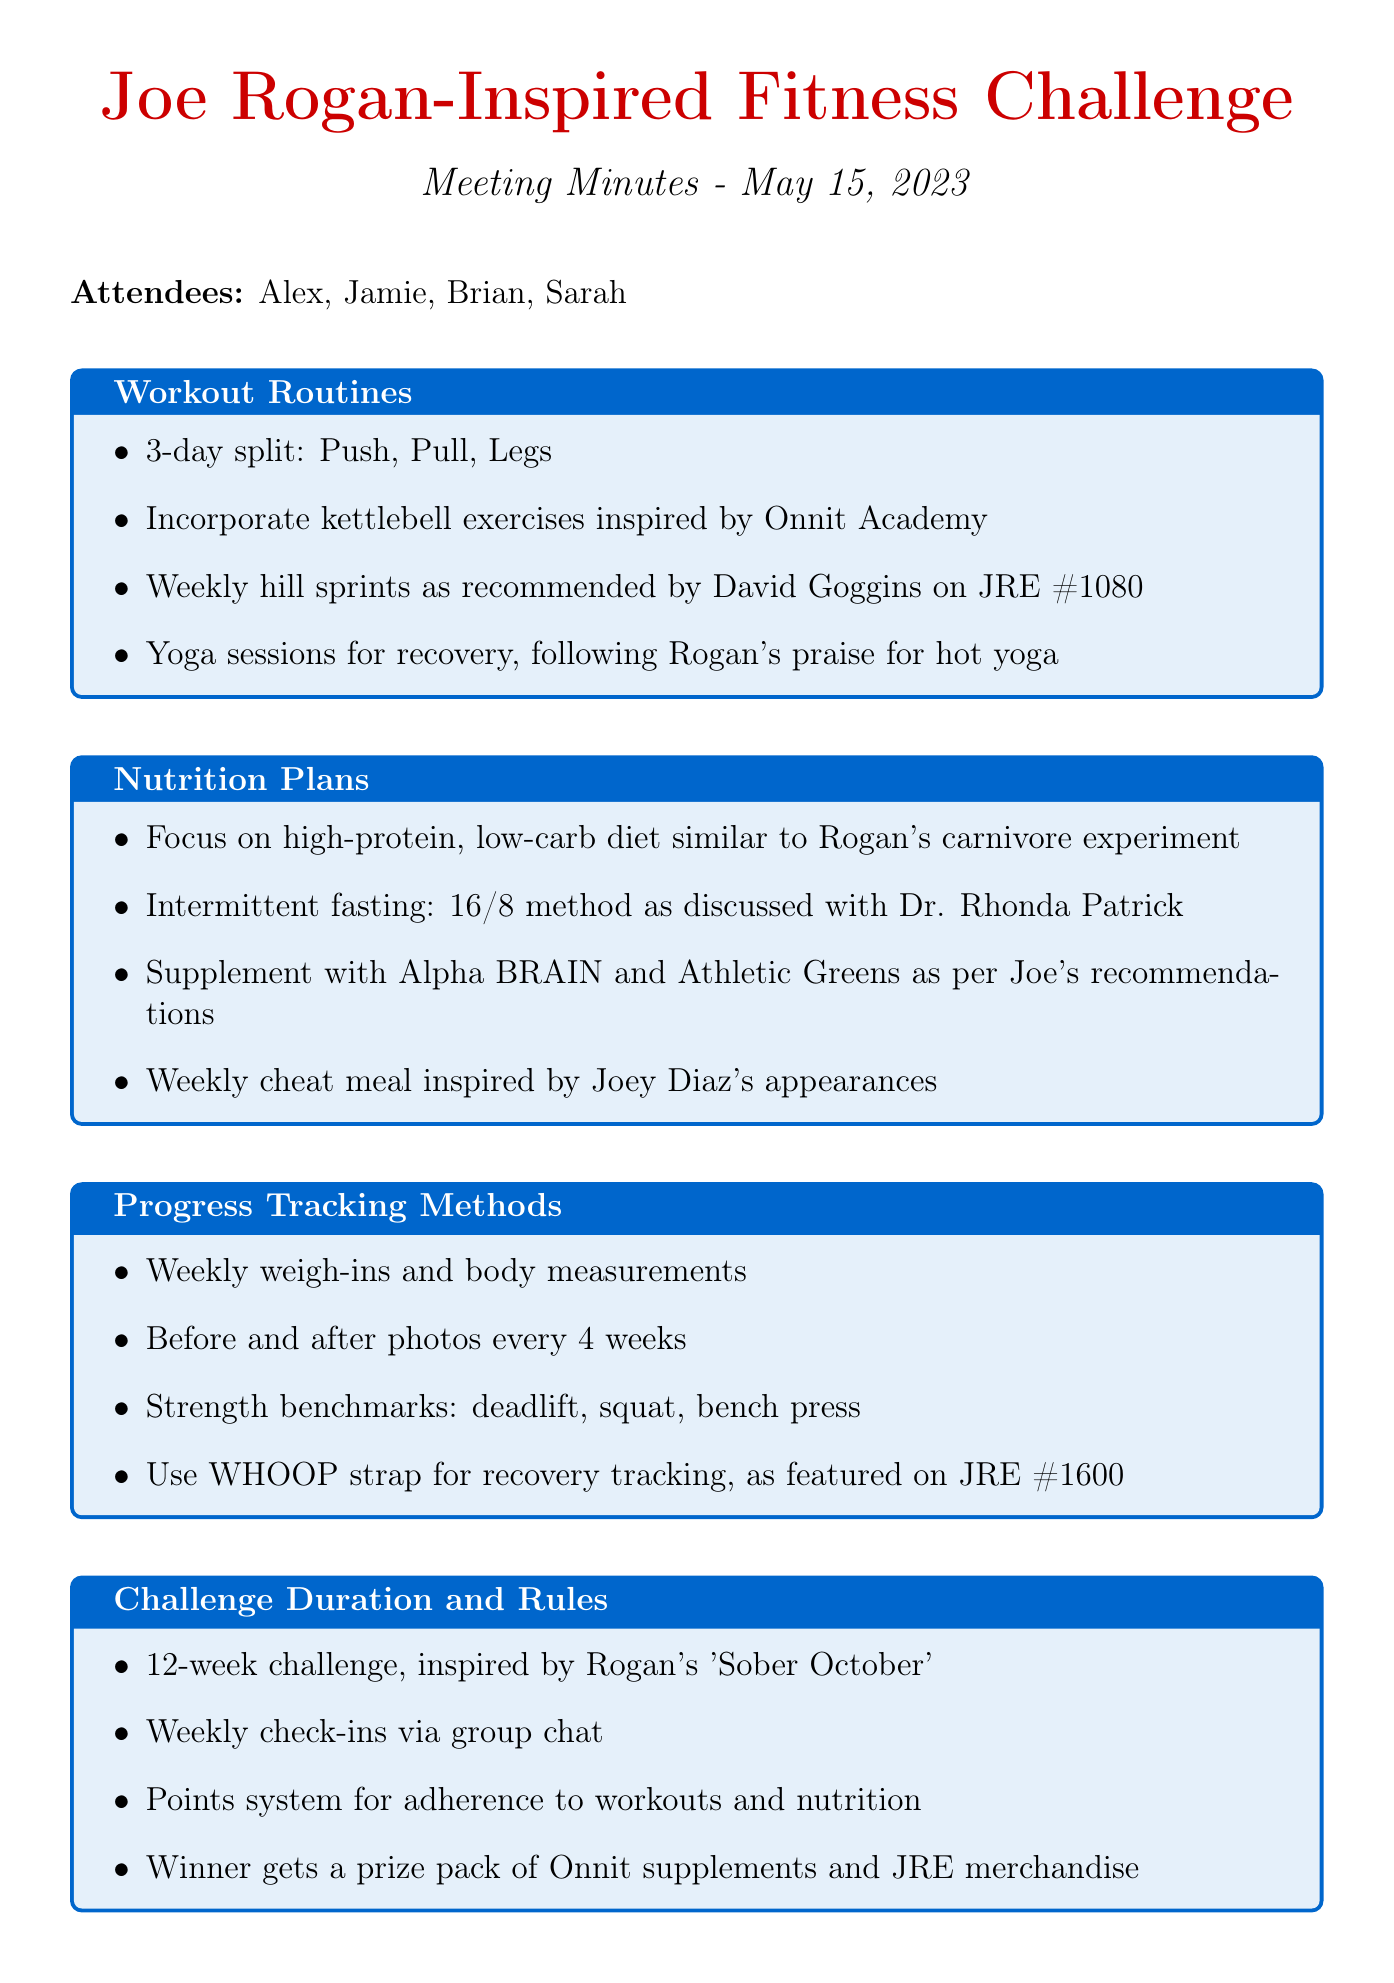What is the title of the meeting? The title of the meeting is listed at the beginning of the document.
Answer: Joe Rogan-Inspired Fitness Challenge Planning When was the meeting held? The date of the meeting is mentioned in the document header.
Answer: 2023-05-15 Who are the attendees? The attendees are listed together in the document.
Answer: Alex, Jamie, Brian, Sarah How long is the challenge duration? The challenge duration is explicitly mentioned in the section about Challenge Duration and Rules.
Answer: 12 weeks What type of diet is recommended? The recommended diet type is provided under the Nutrition Plans section.
Answer: high-protein, low-carb diet What is one method used for progress tracking? The progress tracking methods are outlined in their respective section of the document.
Answer: Weekly weigh-ins and body measurements What supplement is suggested for this challenge? The suggested supplement is listed under Nutrition Plans.
Answer: Alpha BRAIN Who is responsible for creating a shared Google Sheet? The person assigned to this action item is mentioned in the action items section of the document.
Answer: Alex What is the prize for the winner of the challenge? The prize for the winner is stated within the Challenge Duration and Rules section.
Answer: Onnit supplements and JRE merchandise 